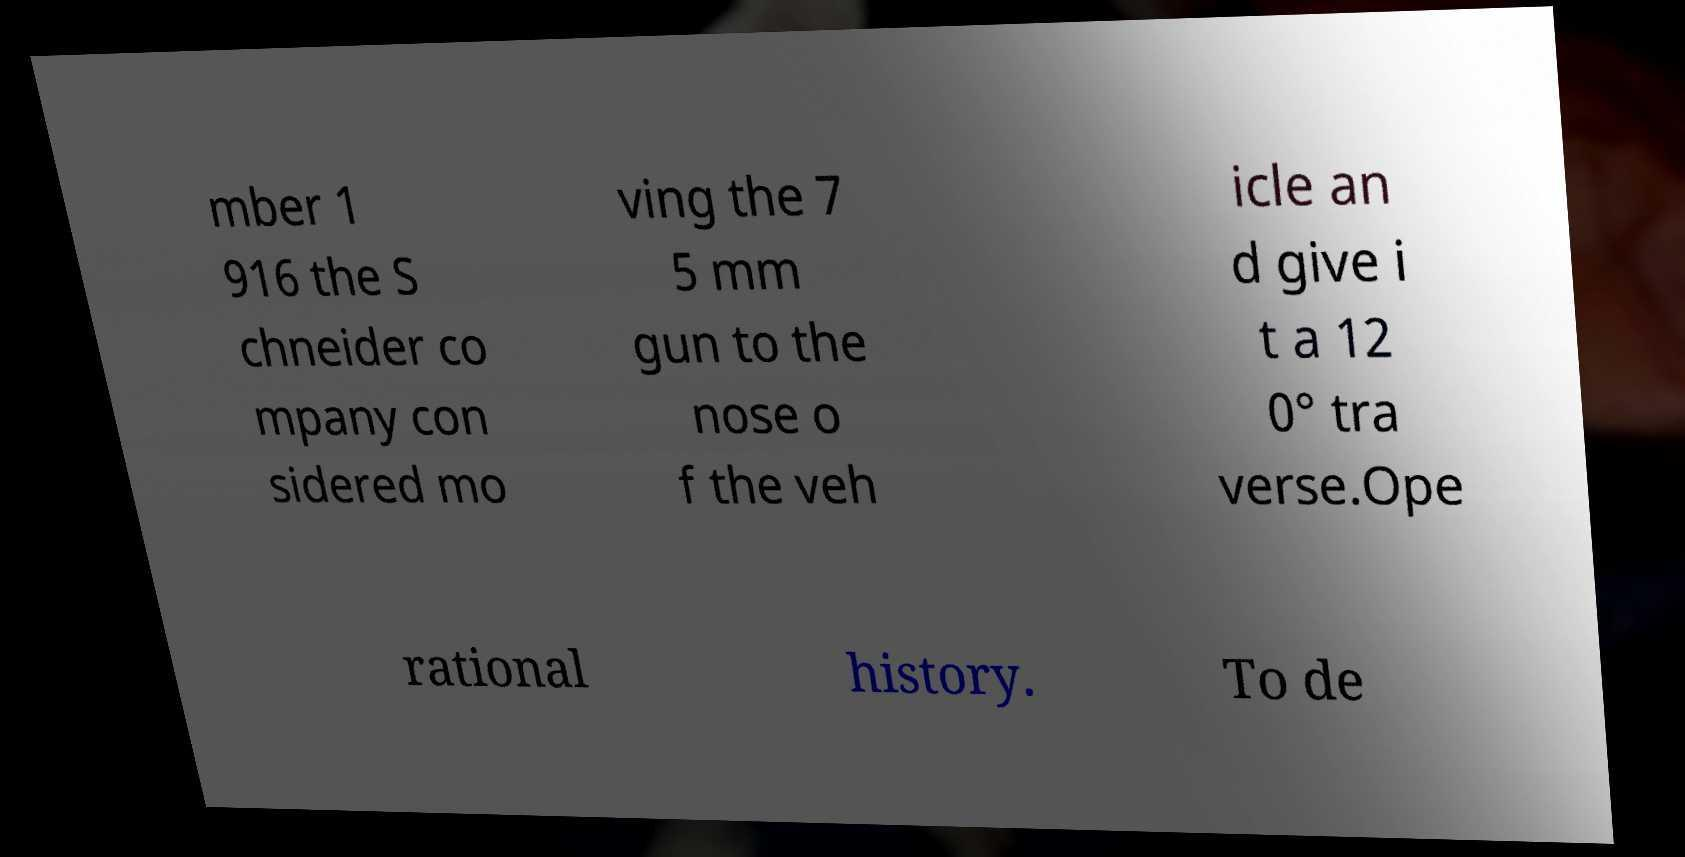For documentation purposes, I need the text within this image transcribed. Could you provide that? mber 1 916 the S chneider co mpany con sidered mo ving the 7 5 mm gun to the nose o f the veh icle an d give i t a 12 0° tra verse.Ope rational history. To de 